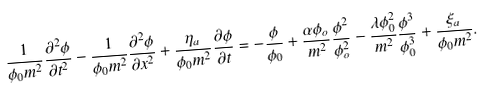Convert formula to latex. <formula><loc_0><loc_0><loc_500><loc_500>\frac { 1 } { \phi _ { 0 } m ^ { 2 } } \frac { \partial ^ { 2 } \phi } { \partial t ^ { 2 } } - \frac { 1 } { \phi _ { 0 } m ^ { 2 } } \frac { \partial ^ { 2 } \phi } { \partial x ^ { 2 } } + \frac { \eta _ { a } } { \phi _ { 0 } m ^ { 2 } } \frac { \partial \phi } { \partial t } = - \frac { \phi } { \phi _ { 0 } } + \frac { \alpha \phi _ { o } } { m ^ { 2 } } \frac { \phi ^ { 2 } } { \phi _ { o } ^ { 2 } } - \frac { \lambda \phi _ { 0 } ^ { 2 } } { m ^ { 2 } } \frac { \phi ^ { 3 } } { \phi _ { 0 } ^ { 3 } } + \frac { \xi _ { a } } { \phi _ { 0 } m ^ { 2 } } .</formula> 